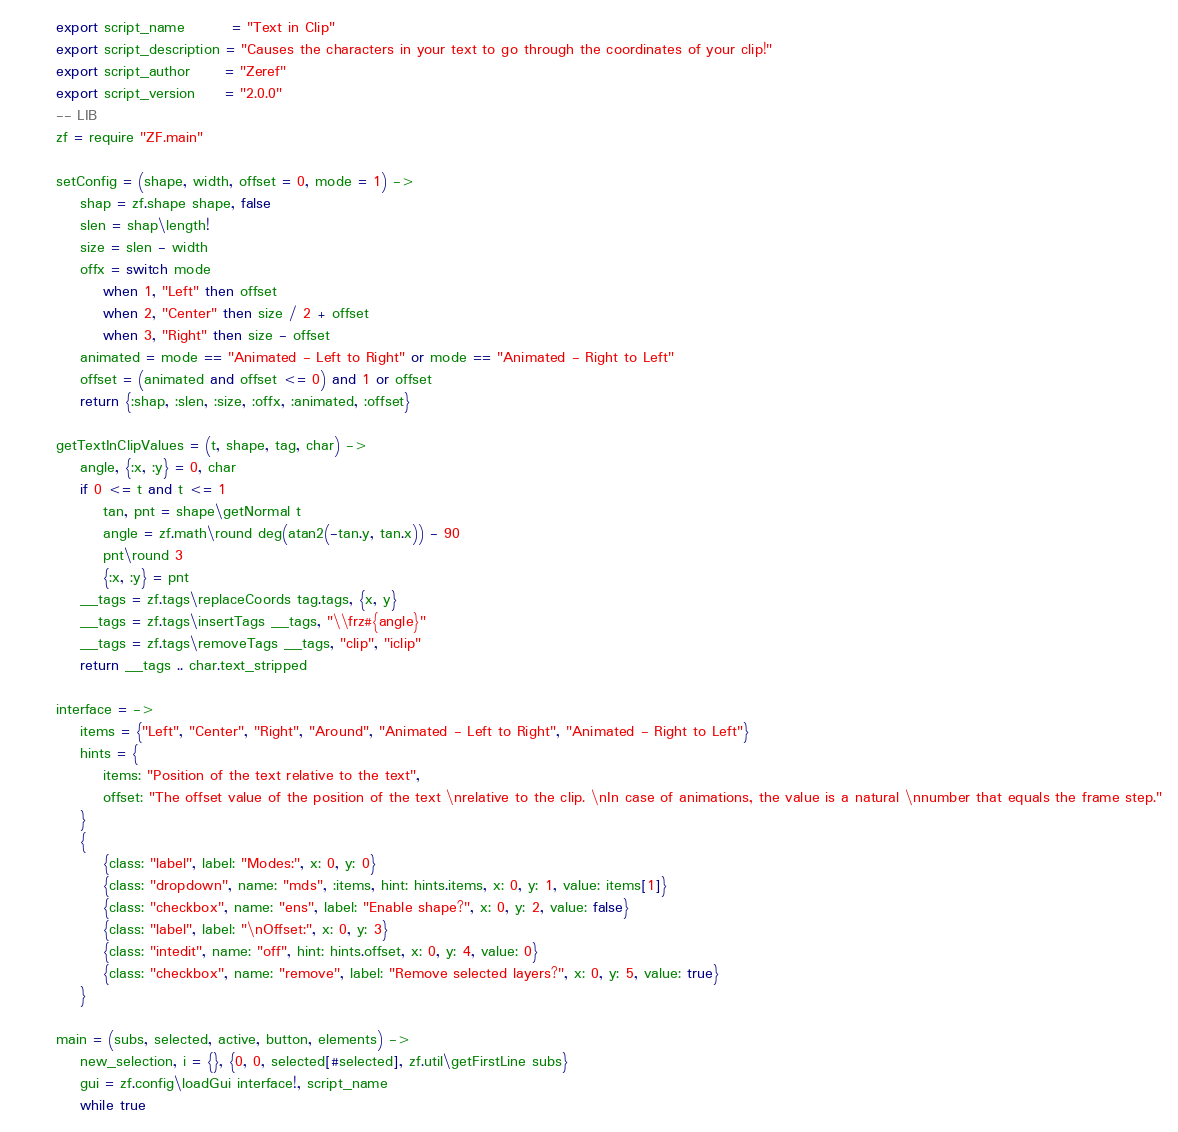<code> <loc_0><loc_0><loc_500><loc_500><_MoonScript_>export script_name        = "Text in Clip"
export script_description = "Causes the characters in your text to go through the coordinates of your clip!"
export script_author      = "Zeref"
export script_version     = "2.0.0"
-- LIB
zf = require "ZF.main"

setConfig = (shape, width, offset = 0, mode = 1) ->
    shap = zf.shape shape, false
    slen = shap\length!
    size = slen - width
    offx = switch mode
        when 1, "Left" then offset
        when 2, "Center" then size / 2 + offset
        when 3, "Right" then size - offset
    animated = mode == "Animated - Left to Right" or mode == "Animated - Right to Left"
    offset = (animated and offset <= 0) and 1 or offset
    return {:shap, :slen, :size, :offx, :animated, :offset}

getTextInClipValues = (t, shape, tag, char) ->
    angle, {:x, :y} = 0, char
    if 0 <= t and t <= 1
        tan, pnt = shape\getNormal t
        angle = zf.math\round deg(atan2(-tan.y, tan.x)) - 90
        pnt\round 3
        {:x, :y} = pnt
    __tags = zf.tags\replaceCoords tag.tags, {x, y}
    __tags = zf.tags\insertTags __tags, "\\frz#{angle}"
    __tags = zf.tags\removeTags __tags, "clip", "iclip"
    return __tags .. char.text_stripped

interface = ->
    items = {"Left", "Center", "Right", "Around", "Animated - Left to Right", "Animated - Right to Left"}
    hints = {
        items: "Position of the text relative to the text",
        offset: "The offset value of the position of the text \nrelative to the clip. \nIn case of animations, the value is a natural \nnumber that equals the frame step."
    }
    {
        {class: "label", label: "Modes:", x: 0, y: 0}
        {class: "dropdown", name: "mds", :items, hint: hints.items, x: 0, y: 1, value: items[1]}
        {class: "checkbox", name: "ens", label: "Enable shape?", x: 0, y: 2, value: false}
        {class: "label", label: "\nOffset:", x: 0, y: 3}
        {class: "intedit", name: "off", hint: hints.offset, x: 0, y: 4, value: 0}
        {class: "checkbox", name: "remove", label: "Remove selected layers?", x: 0, y: 5, value: true}
    }

main = (subs, selected, active, button, elements) ->
    new_selection, i = {}, {0, 0, selected[#selected], zf.util\getFirstLine subs}
    gui = zf.config\loadGui interface!, script_name
    while true</code> 